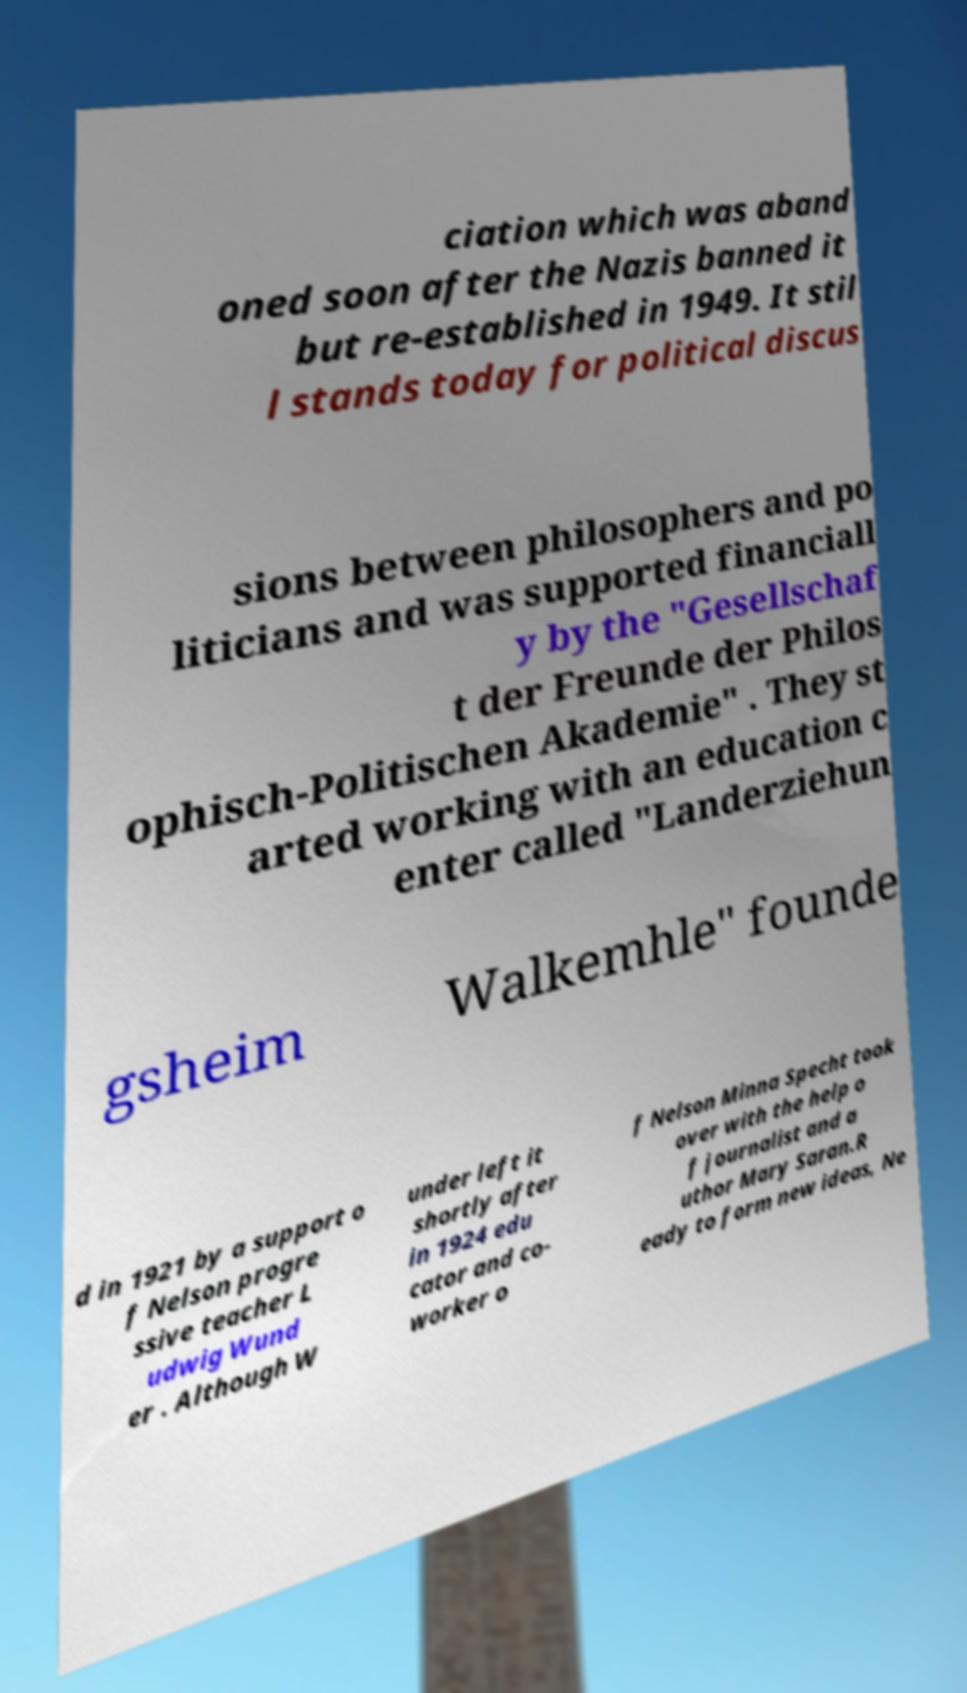What messages or text are displayed in this image? I need them in a readable, typed format. ciation which was aband oned soon after the Nazis banned it but re-established in 1949. It stil l stands today for political discus sions between philosophers and po liticians and was supported financiall y by the "Gesellschaf t der Freunde der Philos ophisch-Politischen Akademie" . They st arted working with an education c enter called "Landerziehun gsheim Walkemhle" founde d in 1921 by a support o f Nelson progre ssive teacher L udwig Wund er . Although W under left it shortly after in 1924 edu cator and co- worker o f Nelson Minna Specht took over with the help o f journalist and a uthor Mary Saran.R eady to form new ideas, Ne 